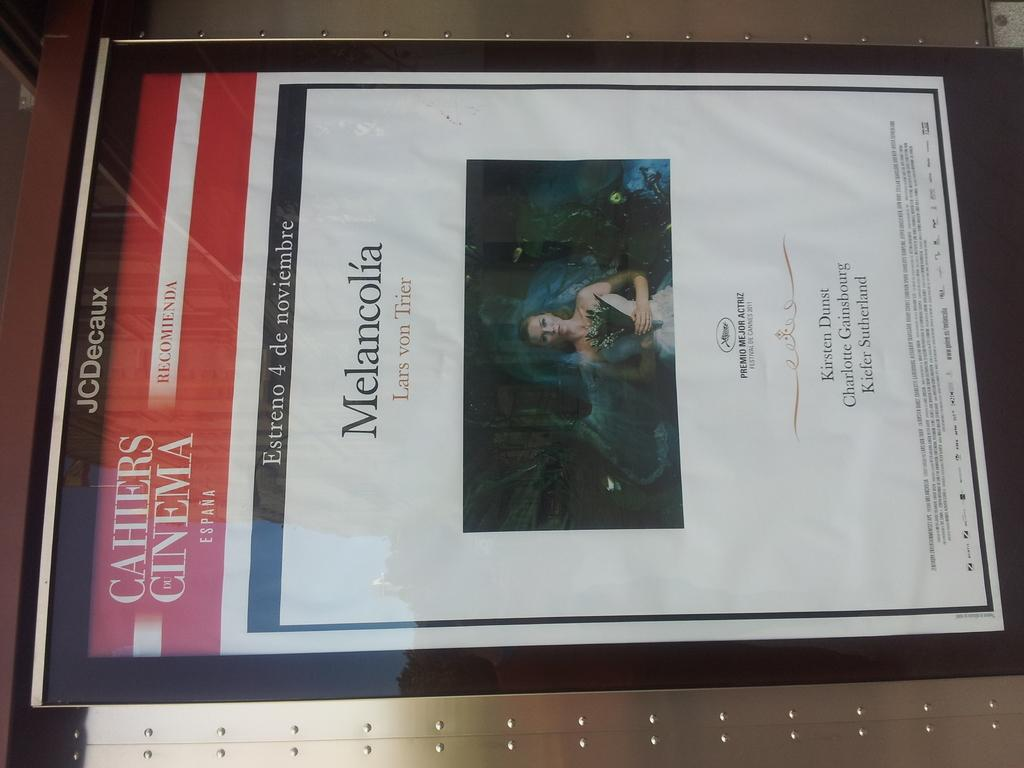<image>
Relay a brief, clear account of the picture shown. a sheet of paper that has Melancolia written on it 